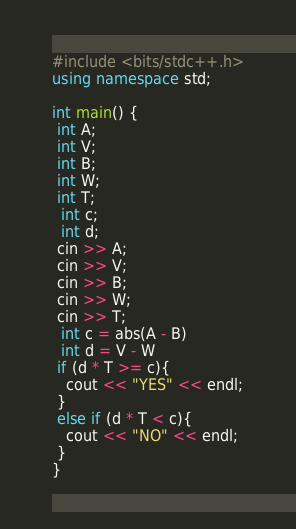Convert code to text. <code><loc_0><loc_0><loc_500><loc_500><_C++_>#include <bits/stdc++.h>
using namespace std;
 
int main() {
 int A;
 int V;
 int B;
 int W;
 int T;
  int c;
  int d;
 cin >> A;
 cin >> V;
 cin >> B;
 cin >> W;
 cin >> T;
  int c = abs(A - B)
  int d = V - W
 if (d * T >= c){
   cout << "YES" << endl;
 }
 else if (d * T < c){
   cout << "NO" << endl;
 }
}</code> 